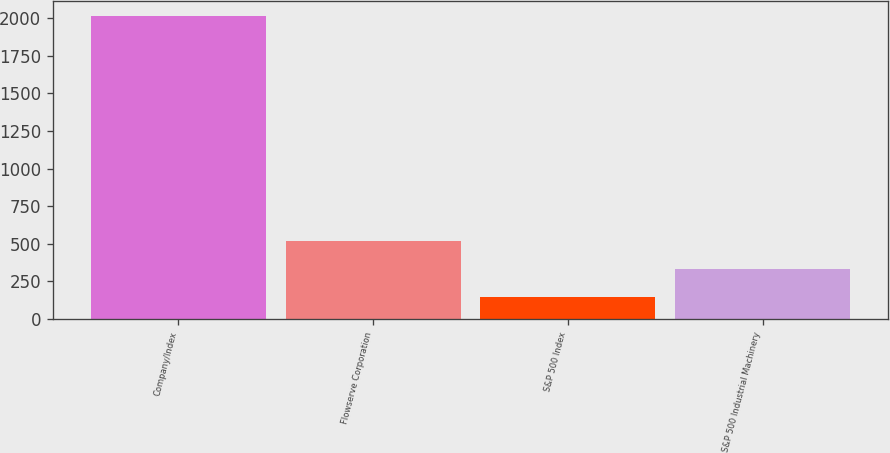Convert chart. <chart><loc_0><loc_0><loc_500><loc_500><bar_chart><fcel>Company/Index<fcel>Flowserve Corporation<fcel>S&P 500 Index<fcel>S&P 500 Industrial Machinery<nl><fcel>2010<fcel>518.39<fcel>145.49<fcel>331.94<nl></chart> 